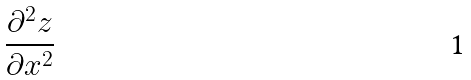<formula> <loc_0><loc_0><loc_500><loc_500>\frac { \partial ^ { 2 } z } { \partial x ^ { 2 } }</formula> 